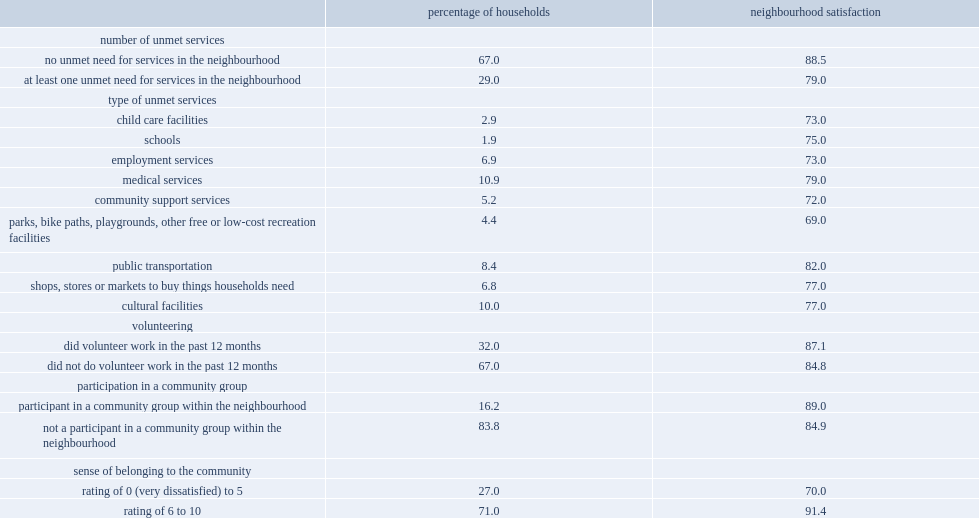Among these households, how many percent were satisfied with their neighbourhood? 79.0. Among other households, how many percent were satisfied with their neighbourhood? 88.5. Among the list of services enumerated in the 2018 chs, what was the percent of medical services-such as community health centres and hospitals-were the services reported as unmet most often by canadian households? 10.9. Schools were the services reported least often by households as being unmet, what was the percent of households reporting an unmet need for a school in their neighbourhood? 1.9. Which sense of belonging to the community did these households have a higher neighbourhood satisfaction rate? Rating of 6 to 10. 